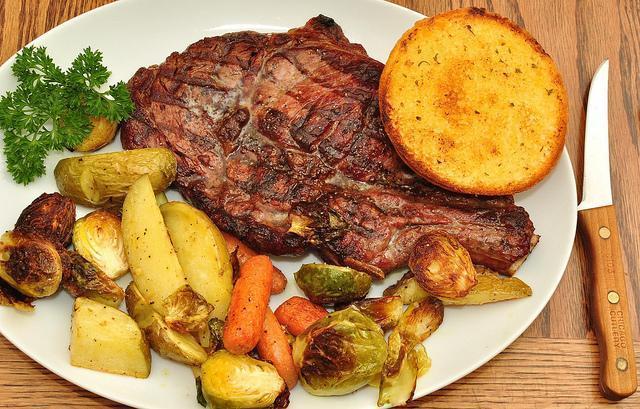How many women are pictured?
Give a very brief answer. 0. 